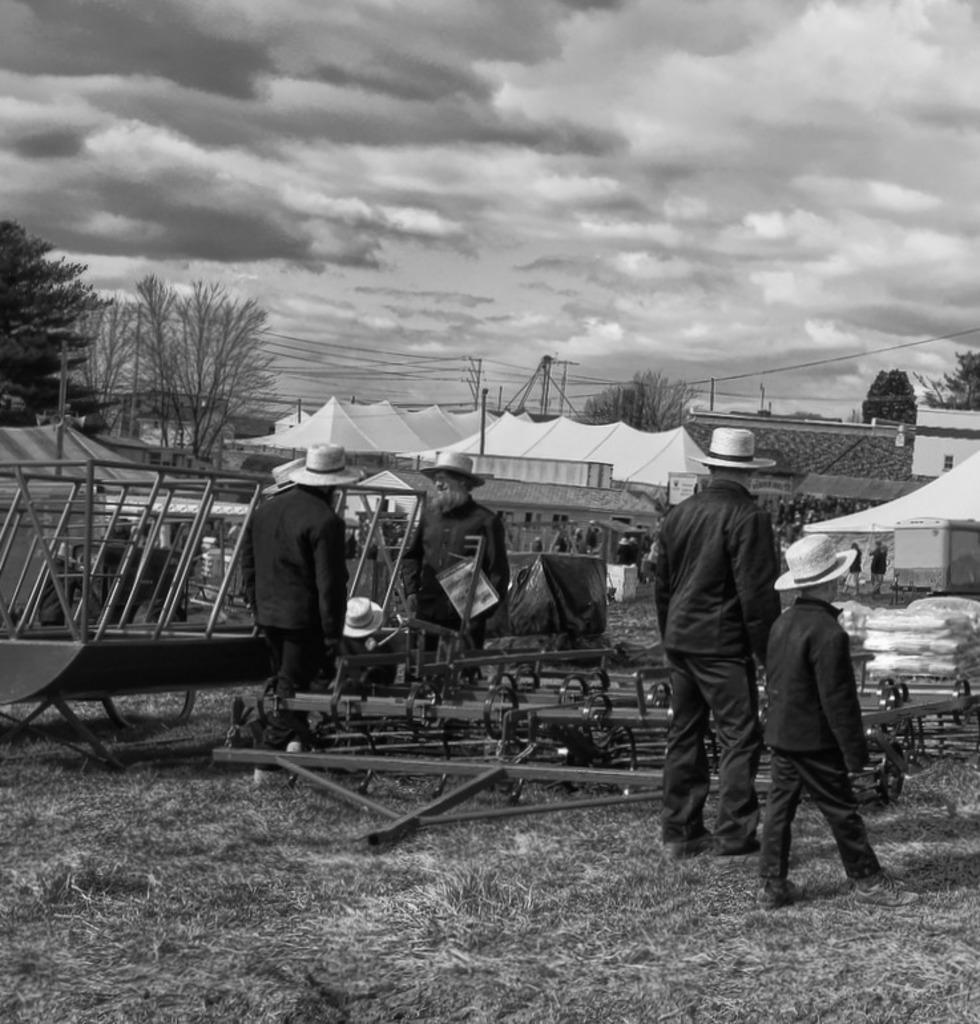Could you give a brief overview of what you see in this image? In this image, we can see some people standing, there are some white color tents, there are some trees, at the top there is a sky which is cloudy. 